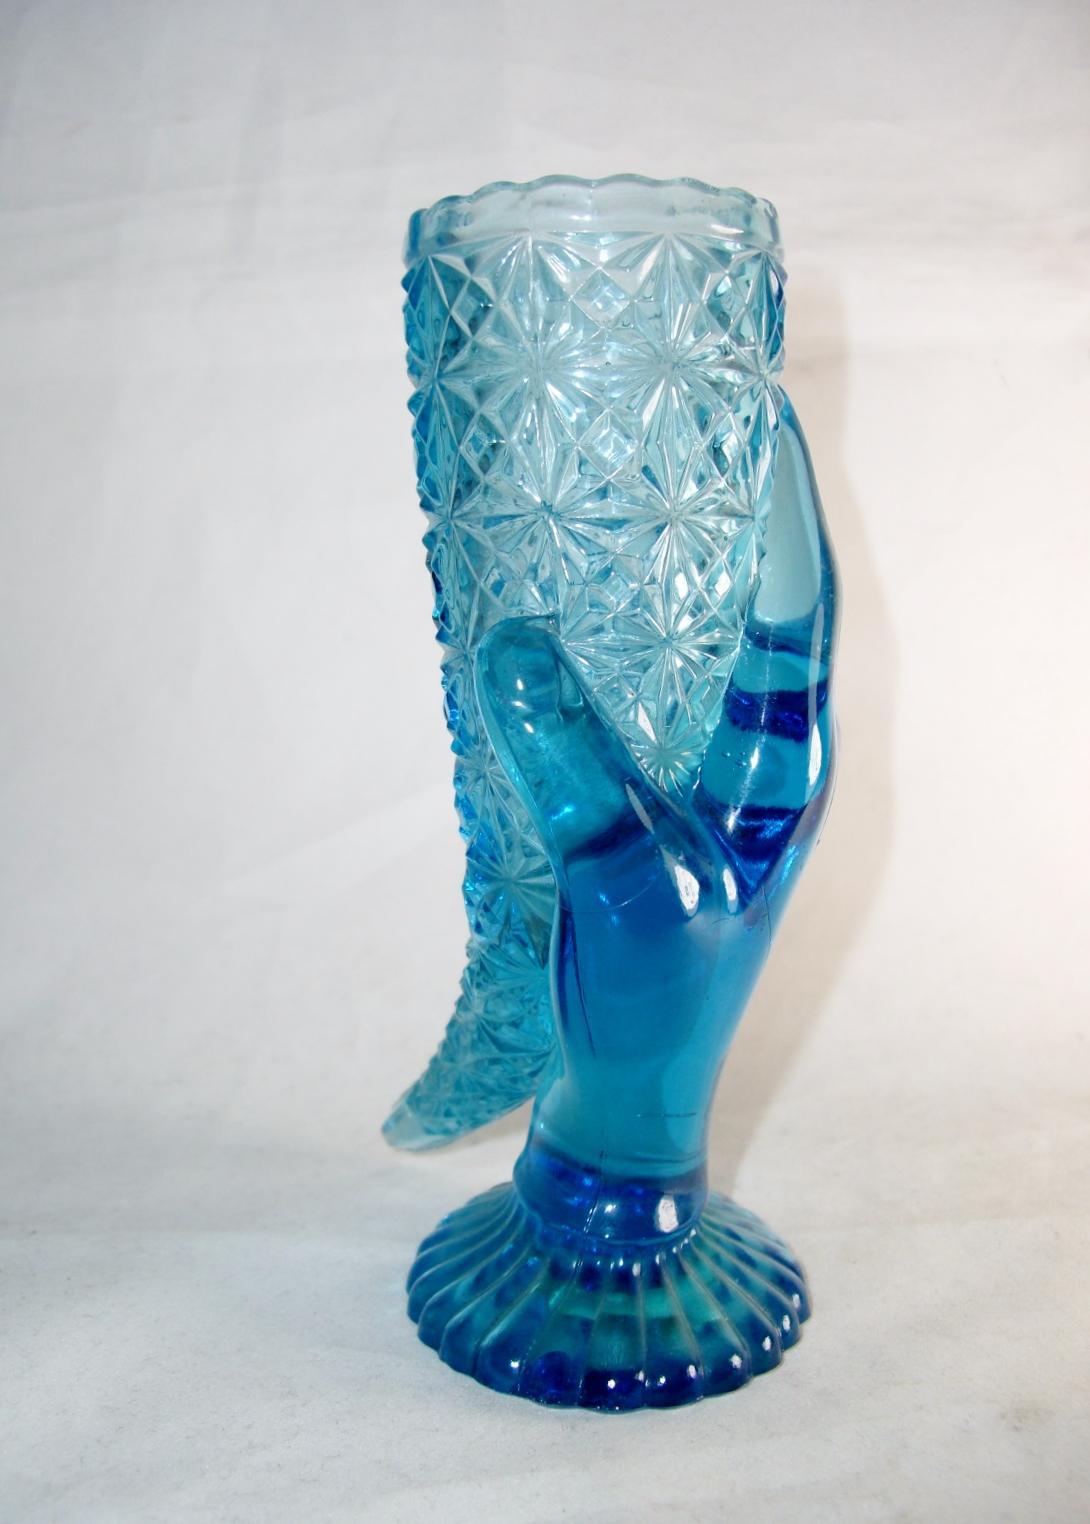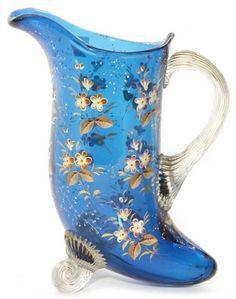The first image is the image on the left, the second image is the image on the right. Given the left and right images, does the statement "An image shows one translucent blue vase with a deep blue non-scalloped base." hold true? Answer yes or no. No. The first image is the image on the left, the second image is the image on the right. Considering the images on both sides, is "there are blue glass vases with black bottoms" valid? Answer yes or no. No. 